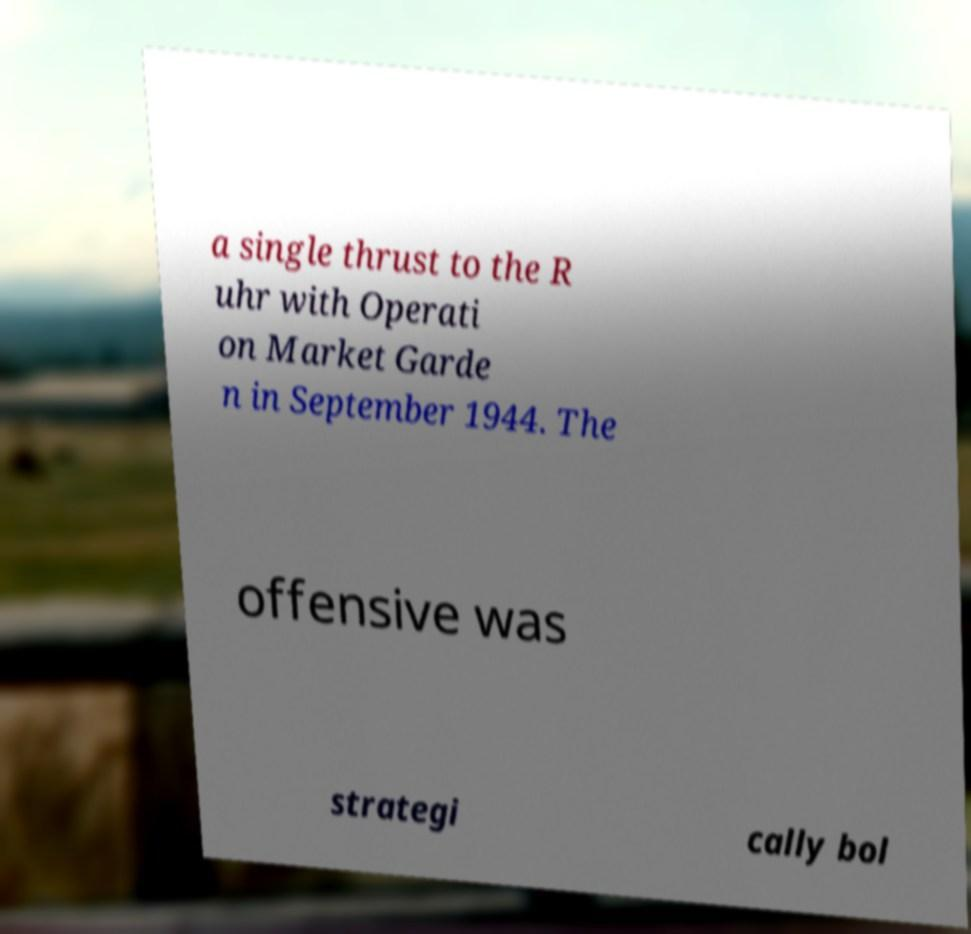Please identify and transcribe the text found in this image. a single thrust to the R uhr with Operati on Market Garde n in September 1944. The offensive was strategi cally bol 